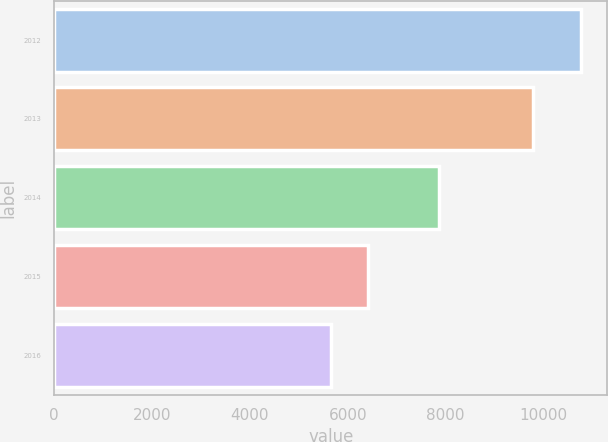Convert chart to OTSL. <chart><loc_0><loc_0><loc_500><loc_500><bar_chart><fcel>2012<fcel>2013<fcel>2014<fcel>2015<fcel>2016<nl><fcel>10767<fcel>9787<fcel>7869<fcel>6404<fcel>5664<nl></chart> 